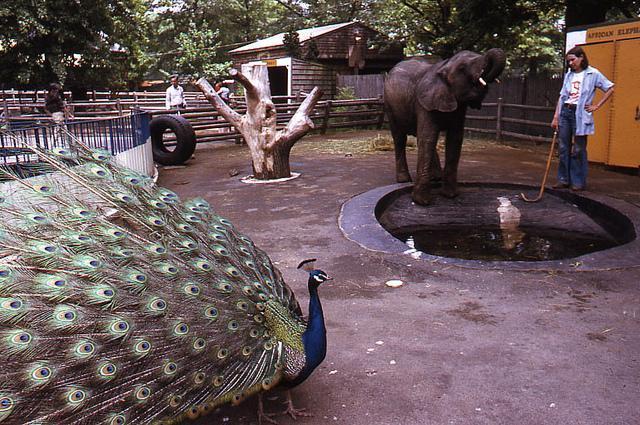Is "The bird is behind the elephant." an appropriate description for the image?
Answer yes or no. No. Evaluate: Does the caption "The elephant is beneath the bird." match the image?
Answer yes or no. No. Does the caption "The elephant is next to the bird." correctly depict the image?
Answer yes or no. No. Is the given caption "The bird is far from the elephant." fitting for the image?
Answer yes or no. Yes. 